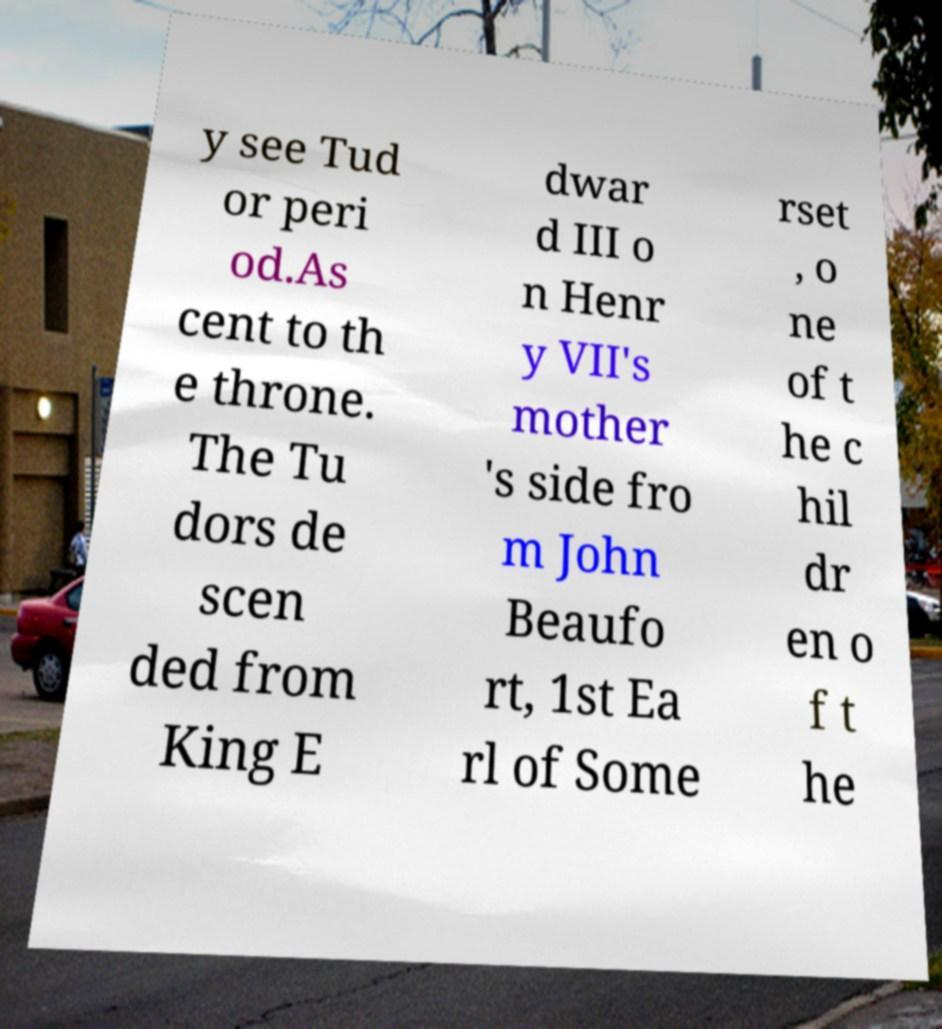Please read and relay the text visible in this image. What does it say? y see Tud or peri od.As cent to th e throne. The Tu dors de scen ded from King E dwar d III o n Henr y VII's mother 's side fro m John Beaufo rt, 1st Ea rl of Some rset , o ne of t he c hil dr en o f t he 